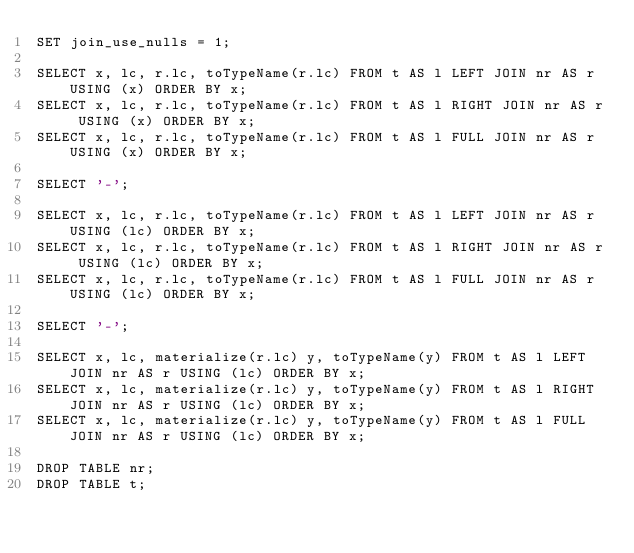<code> <loc_0><loc_0><loc_500><loc_500><_SQL_>SET join_use_nulls = 1;

SELECT x, lc, r.lc, toTypeName(r.lc) FROM t AS l LEFT JOIN nr AS r USING (x) ORDER BY x;
SELECT x, lc, r.lc, toTypeName(r.lc) FROM t AS l RIGHT JOIN nr AS r USING (x) ORDER BY x;
SELECT x, lc, r.lc, toTypeName(r.lc) FROM t AS l FULL JOIN nr AS r USING (x) ORDER BY x;

SELECT '-';

SELECT x, lc, r.lc, toTypeName(r.lc) FROM t AS l LEFT JOIN nr AS r USING (lc) ORDER BY x;
SELECT x, lc, r.lc, toTypeName(r.lc) FROM t AS l RIGHT JOIN nr AS r USING (lc) ORDER BY x;
SELECT x, lc, r.lc, toTypeName(r.lc) FROM t AS l FULL JOIN nr AS r USING (lc) ORDER BY x;

SELECT '-';

SELECT x, lc, materialize(r.lc) y, toTypeName(y) FROM t AS l LEFT JOIN nr AS r USING (lc) ORDER BY x;
SELECT x, lc, materialize(r.lc) y, toTypeName(y) FROM t AS l RIGHT JOIN nr AS r USING (lc) ORDER BY x;
SELECT x, lc, materialize(r.lc) y, toTypeName(y) FROM t AS l FULL JOIN nr AS r USING (lc) ORDER BY x;

DROP TABLE nr;
DROP TABLE t;
</code> 